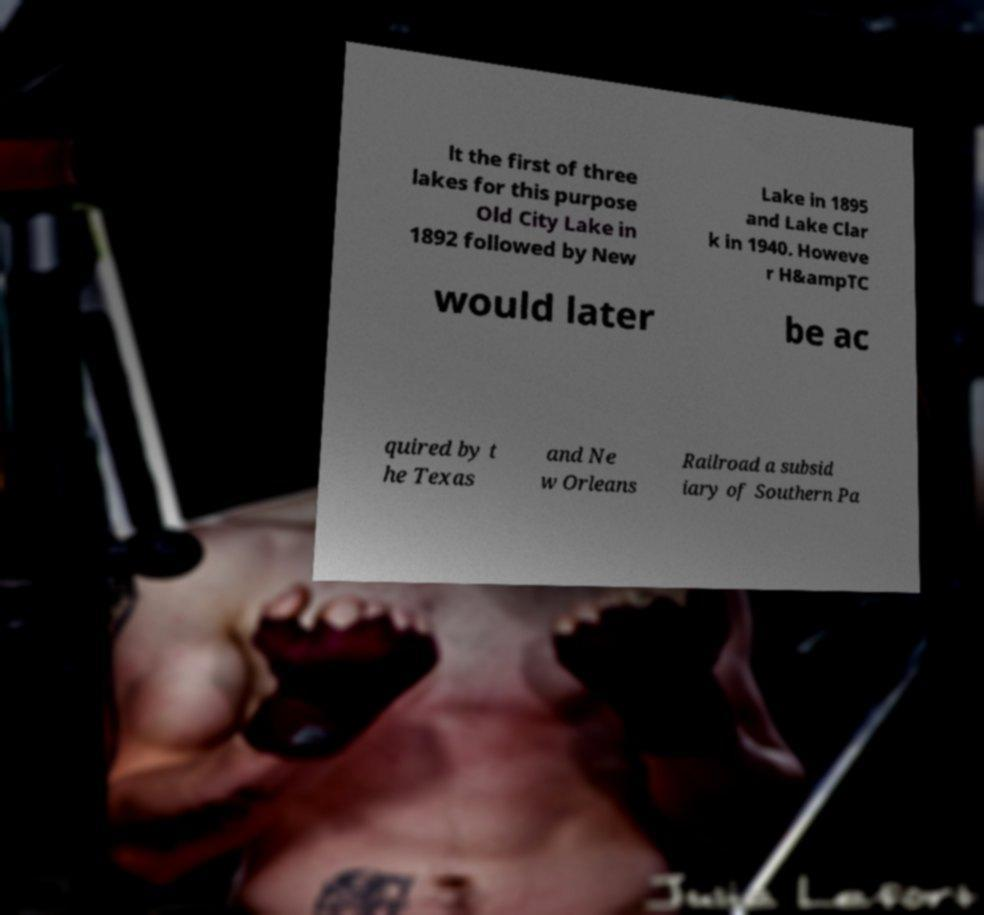Could you extract and type out the text from this image? lt the first of three lakes for this purpose Old City Lake in 1892 followed by New Lake in 1895 and Lake Clar k in 1940. Howeve r H&ampTC would later be ac quired by t he Texas and Ne w Orleans Railroad a subsid iary of Southern Pa 